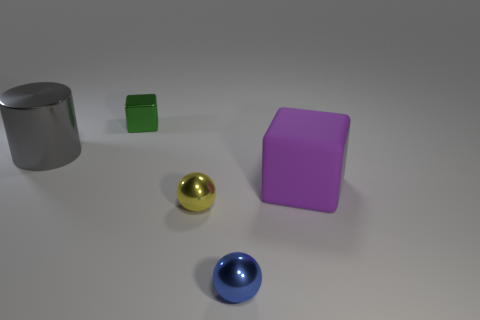Is there any other thing that is made of the same material as the large purple object?
Give a very brief answer. No. Are the ball behind the blue sphere and the green block made of the same material?
Your answer should be very brief. Yes. What shape is the purple rubber thing?
Offer a terse response. Cube. How many green things are either large things or metallic cylinders?
Your response must be concise. 0. What number of other things are there of the same material as the small yellow thing
Ensure brevity in your answer.  3. There is a thing that is on the right side of the blue metallic sphere; is its shape the same as the small green thing?
Offer a terse response. Yes. Is there a small yellow rubber cylinder?
Provide a succinct answer. No. Is there anything else that has the same shape as the gray shiny thing?
Provide a short and direct response. No. Are there more tiny shiny things behind the small yellow sphere than tiny blue cylinders?
Your answer should be compact. Yes. There is a tiny yellow metallic object; are there any purple rubber objects behind it?
Ensure brevity in your answer.  Yes. 